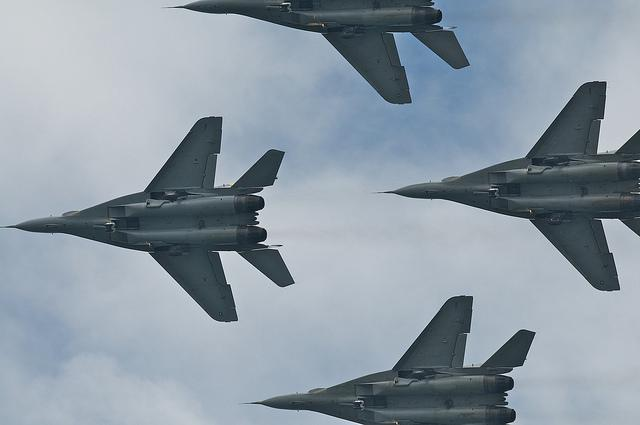The number of items visible in the sky cane be referred to as what?

Choices:
A) quartet
B) legion
C) platoon
D) brigade quartet 